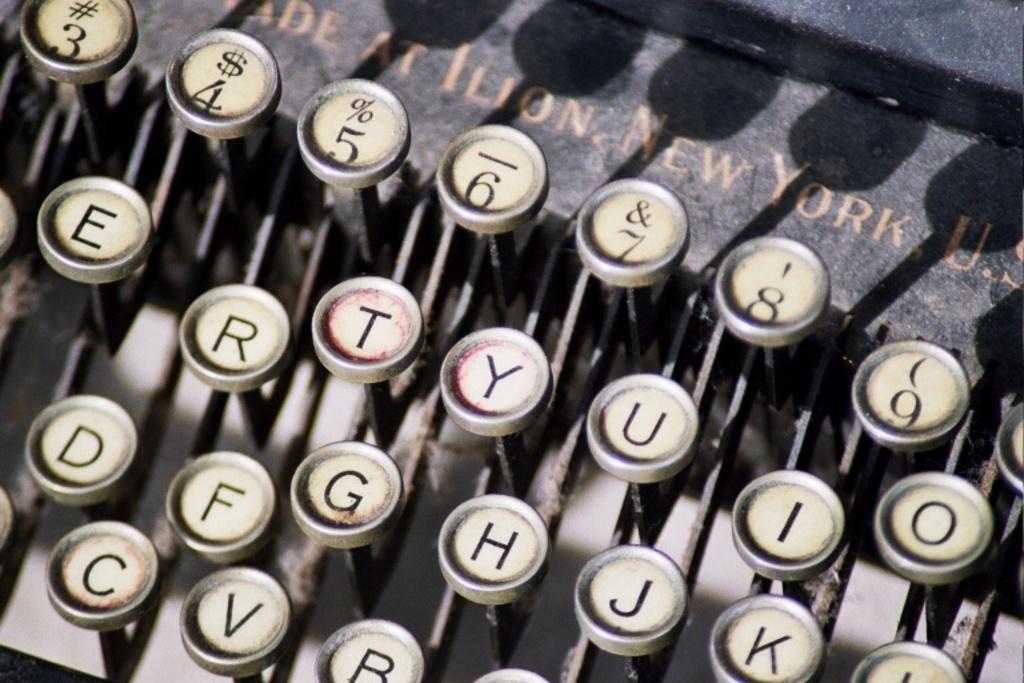What number is the dollar sign?
Your response must be concise. 4. What state was this type writer made?
Ensure brevity in your answer.  New york. 